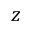<formula> <loc_0><loc_0><loc_500><loc_500>z</formula> 